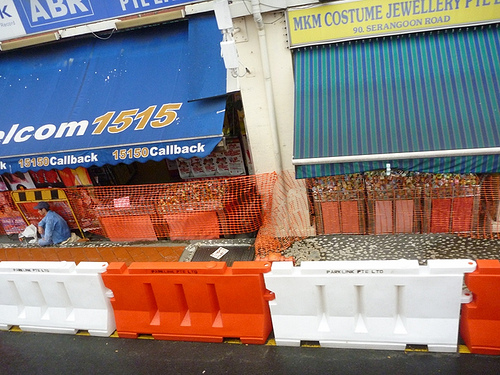<image>
Is there a store above the street? Yes. The store is positioned above the street in the vertical space, higher up in the scene. 